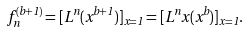<formula> <loc_0><loc_0><loc_500><loc_500>f _ { n } ^ { ( b + 1 ) } = [ L ^ { n } ( x ^ { b + 1 } ) ] _ { x = 1 } = [ L ^ { n } x ( x ^ { b } ) ] _ { x = 1 } .</formula> 